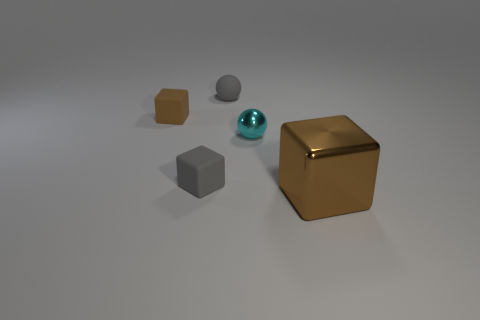Add 1 big green matte spheres. How many objects exist? 6 Subtract all balls. How many objects are left? 3 Subtract all big brown objects. Subtract all purple metallic objects. How many objects are left? 4 Add 5 large brown metallic cubes. How many large brown metallic cubes are left? 6 Add 2 green rubber spheres. How many green rubber spheres exist? 2 Subtract 0 green spheres. How many objects are left? 5 